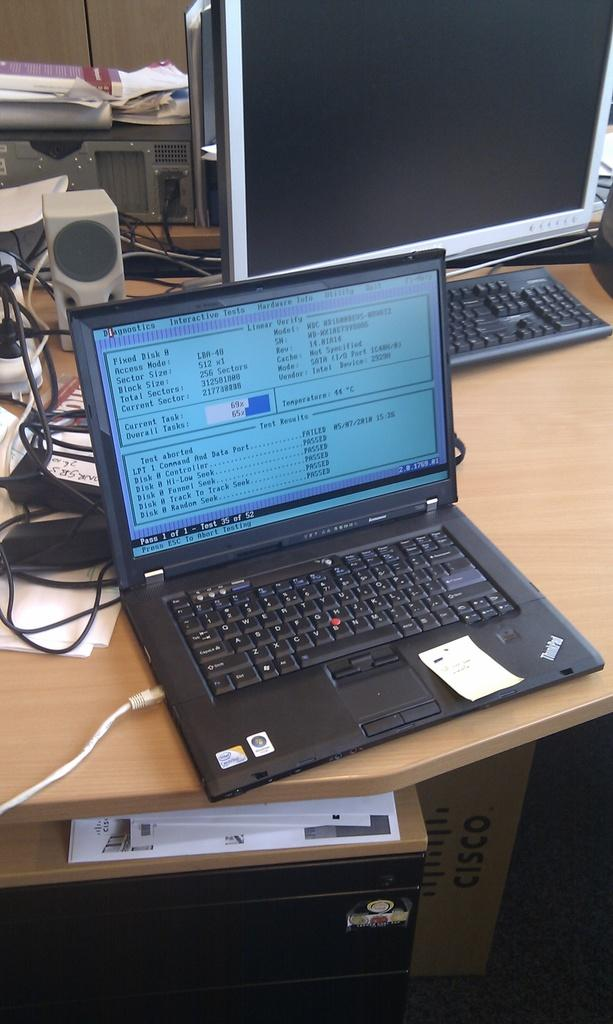What piece of furniture is present in the image? There is a table in the image. What electronic device is on the table? There is a laptop on the table. What other computer accessory is on the table? There is a keyboard on the table. What is used to display the laptop's output? There is a monitor on the table. What connects the devices on the table? There are cables visible on the table. What type of hospital is depicted in the image? There is no hospital present in the image; it features a table with a laptop, keyboard, monitor, and cables. Does the existence of the laptop in the image prove the existence of the internet? The presence of a laptop in the image does not prove the existence of the internet, as the laptop could be disconnected or offline. 